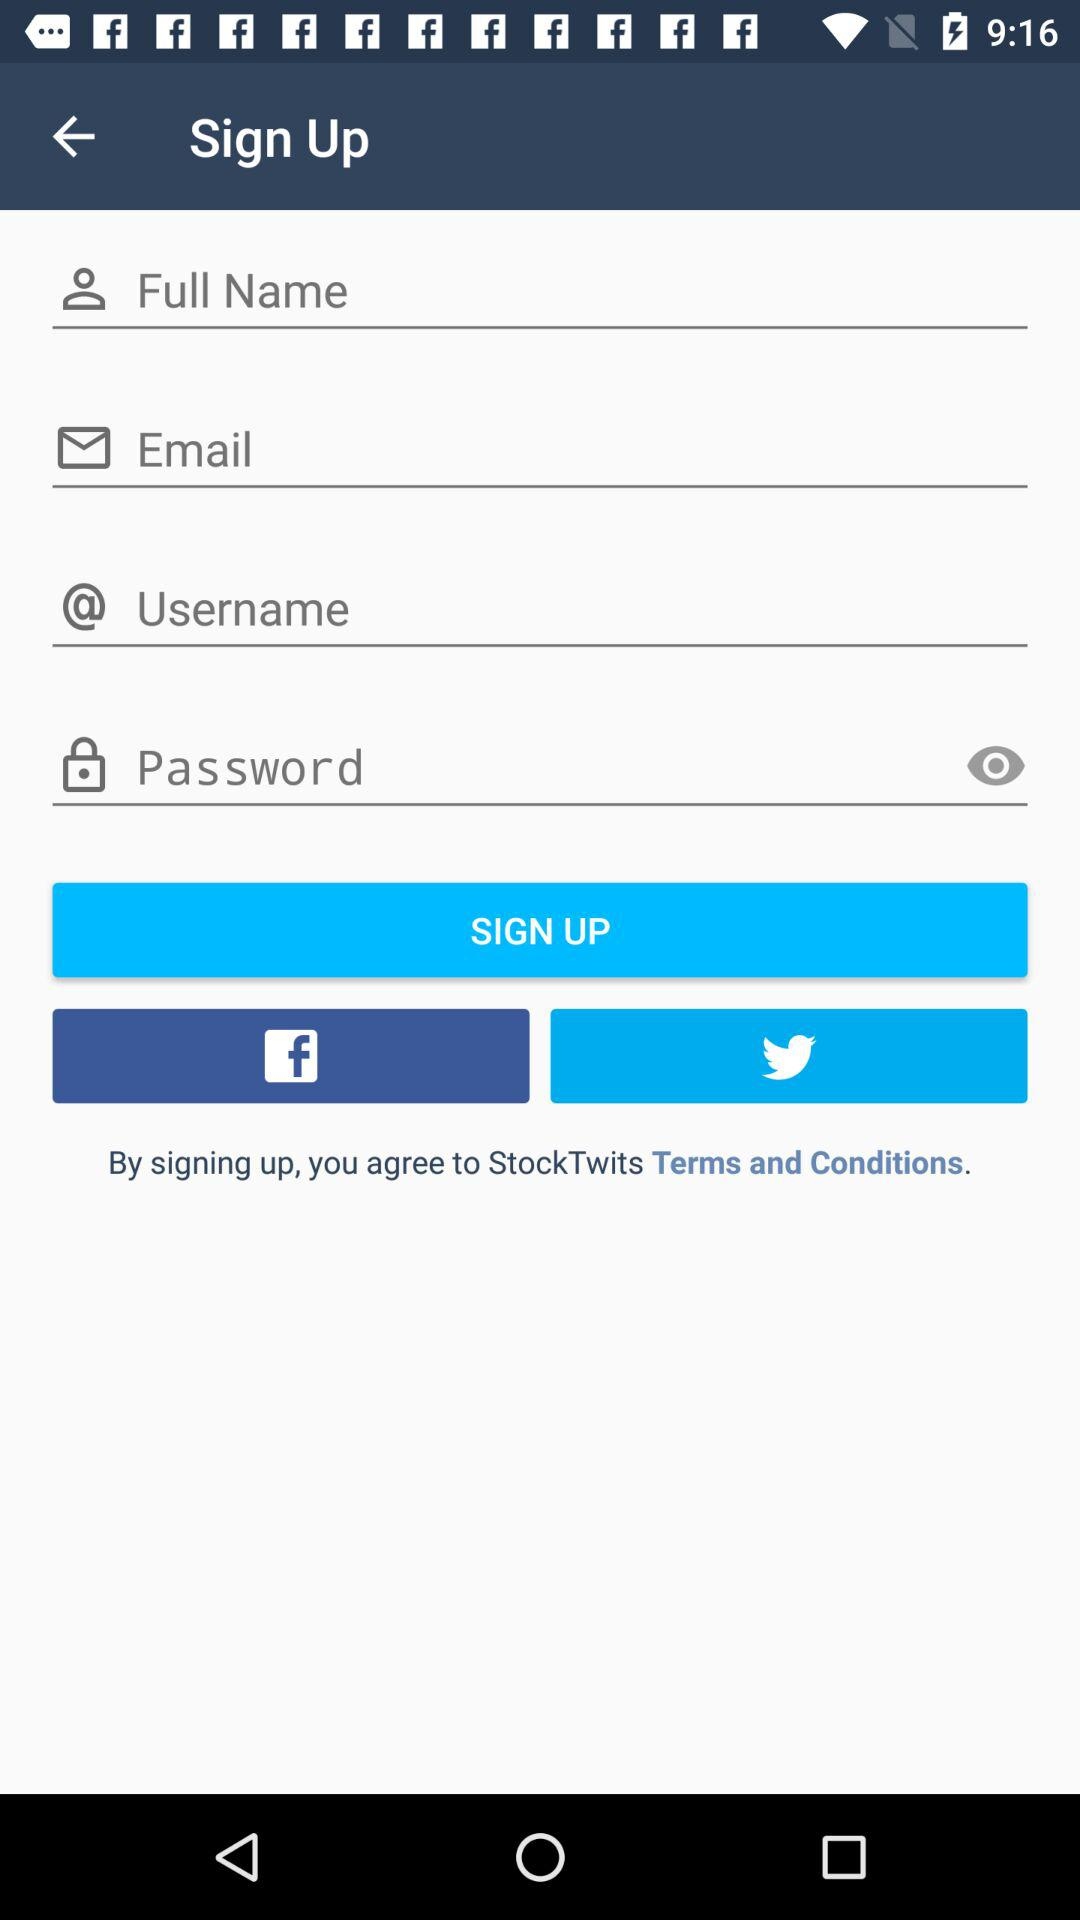What are the different options available for logging in? The different options available for logging in are "Email", "Facebook" and "Twitter". 